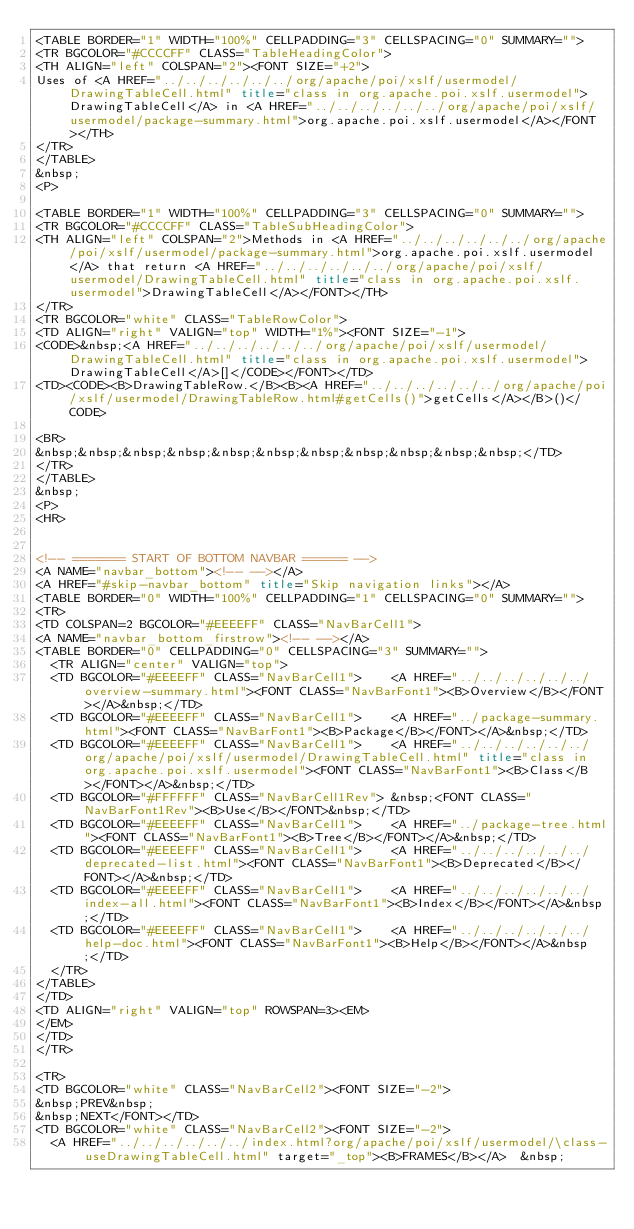<code> <loc_0><loc_0><loc_500><loc_500><_HTML_><TABLE BORDER="1" WIDTH="100%" CELLPADDING="3" CELLSPACING="0" SUMMARY="">
<TR BGCOLOR="#CCCCFF" CLASS="TableHeadingColor">
<TH ALIGN="left" COLSPAN="2"><FONT SIZE="+2">
Uses of <A HREF="../../../../../../org/apache/poi/xslf/usermodel/DrawingTableCell.html" title="class in org.apache.poi.xslf.usermodel">DrawingTableCell</A> in <A HREF="../../../../../../org/apache/poi/xslf/usermodel/package-summary.html">org.apache.poi.xslf.usermodel</A></FONT></TH>
</TR>
</TABLE>
&nbsp;
<P>

<TABLE BORDER="1" WIDTH="100%" CELLPADDING="3" CELLSPACING="0" SUMMARY="">
<TR BGCOLOR="#CCCCFF" CLASS="TableSubHeadingColor">
<TH ALIGN="left" COLSPAN="2">Methods in <A HREF="../../../../../../org/apache/poi/xslf/usermodel/package-summary.html">org.apache.poi.xslf.usermodel</A> that return <A HREF="../../../../../../org/apache/poi/xslf/usermodel/DrawingTableCell.html" title="class in org.apache.poi.xslf.usermodel">DrawingTableCell</A></FONT></TH>
</TR>
<TR BGCOLOR="white" CLASS="TableRowColor">
<TD ALIGN="right" VALIGN="top" WIDTH="1%"><FONT SIZE="-1">
<CODE>&nbsp;<A HREF="../../../../../../org/apache/poi/xslf/usermodel/DrawingTableCell.html" title="class in org.apache.poi.xslf.usermodel">DrawingTableCell</A>[]</CODE></FONT></TD>
<TD><CODE><B>DrawingTableRow.</B><B><A HREF="../../../../../../org/apache/poi/xslf/usermodel/DrawingTableRow.html#getCells()">getCells</A></B>()</CODE>

<BR>
&nbsp;&nbsp;&nbsp;&nbsp;&nbsp;&nbsp;&nbsp;&nbsp;&nbsp;&nbsp;&nbsp;</TD>
</TR>
</TABLE>
&nbsp;
<P>
<HR>


<!-- ======= START OF BOTTOM NAVBAR ====== -->
<A NAME="navbar_bottom"><!-- --></A>
<A HREF="#skip-navbar_bottom" title="Skip navigation links"></A>
<TABLE BORDER="0" WIDTH="100%" CELLPADDING="1" CELLSPACING="0" SUMMARY="">
<TR>
<TD COLSPAN=2 BGCOLOR="#EEEEFF" CLASS="NavBarCell1">
<A NAME="navbar_bottom_firstrow"><!-- --></A>
<TABLE BORDER="0" CELLPADDING="0" CELLSPACING="3" SUMMARY="">
  <TR ALIGN="center" VALIGN="top">
  <TD BGCOLOR="#EEEEFF" CLASS="NavBarCell1">    <A HREF="../../../../../../overview-summary.html"><FONT CLASS="NavBarFont1"><B>Overview</B></FONT></A>&nbsp;</TD>
  <TD BGCOLOR="#EEEEFF" CLASS="NavBarCell1">    <A HREF="../package-summary.html"><FONT CLASS="NavBarFont1"><B>Package</B></FONT></A>&nbsp;</TD>
  <TD BGCOLOR="#EEEEFF" CLASS="NavBarCell1">    <A HREF="../../../../../../org/apache/poi/xslf/usermodel/DrawingTableCell.html" title="class in org.apache.poi.xslf.usermodel"><FONT CLASS="NavBarFont1"><B>Class</B></FONT></A>&nbsp;</TD>
  <TD BGCOLOR="#FFFFFF" CLASS="NavBarCell1Rev"> &nbsp;<FONT CLASS="NavBarFont1Rev"><B>Use</B></FONT>&nbsp;</TD>
  <TD BGCOLOR="#EEEEFF" CLASS="NavBarCell1">    <A HREF="../package-tree.html"><FONT CLASS="NavBarFont1"><B>Tree</B></FONT></A>&nbsp;</TD>
  <TD BGCOLOR="#EEEEFF" CLASS="NavBarCell1">    <A HREF="../../../../../../deprecated-list.html"><FONT CLASS="NavBarFont1"><B>Deprecated</B></FONT></A>&nbsp;</TD>
  <TD BGCOLOR="#EEEEFF" CLASS="NavBarCell1">    <A HREF="../../../../../../index-all.html"><FONT CLASS="NavBarFont1"><B>Index</B></FONT></A>&nbsp;</TD>
  <TD BGCOLOR="#EEEEFF" CLASS="NavBarCell1">    <A HREF="../../../../../../help-doc.html"><FONT CLASS="NavBarFont1"><B>Help</B></FONT></A>&nbsp;</TD>
  </TR>
</TABLE>
</TD>
<TD ALIGN="right" VALIGN="top" ROWSPAN=3><EM>
</EM>
</TD>
</TR>

<TR>
<TD BGCOLOR="white" CLASS="NavBarCell2"><FONT SIZE="-2">
&nbsp;PREV&nbsp;
&nbsp;NEXT</FONT></TD>
<TD BGCOLOR="white" CLASS="NavBarCell2"><FONT SIZE="-2">
  <A HREF="../../../../../../index.html?org/apache/poi/xslf/usermodel/\class-useDrawingTableCell.html" target="_top"><B>FRAMES</B></A>  &nbsp;</code> 